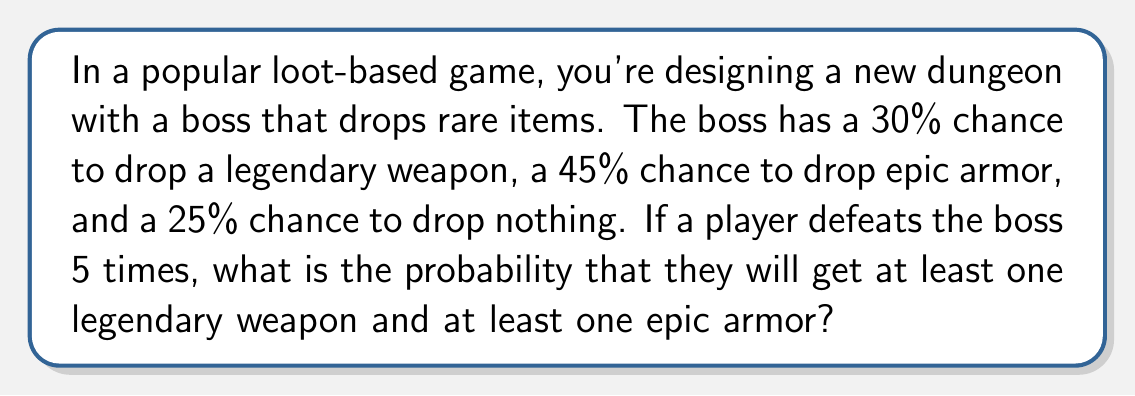Teach me how to tackle this problem. Let's approach this step-by-step:

1) First, we need to calculate the probability of not getting a legendary weapon in a single attempt:
   $P(\text{no legendary}) = 1 - 0.30 = 0.70$

2) The probability of not getting a legendary weapon in 5 attempts is:
   $P(\text{no legendary in 5 attempts}) = 0.70^5 = 0.16807$

3) Therefore, the probability of getting at least one legendary weapon in 5 attempts is:
   $P(\text{at least one legendary}) = 1 - 0.16807 = 0.83193$

4) Similarly for epic armor:
   $P(\text{no epic}) = 1 - 0.45 = 0.55$
   $P(\text{no epic in 5 attempts}) = 0.55^5 = 0.0503284375$
   $P(\text{at least one epic}) = 1 - 0.0503284375 = 0.9496715625$

5) Now, we need the probability of both events occurring. Since these events are independent, we multiply their probabilities:

   $$P(\text{at least one legendary AND at least one epic}) = 0.83193 \times 0.9496715625 = 0.7900372$$

6) Converting to a percentage:
   $0.7900372 \times 100\% = 79.00372\%$
Answer: The probability of getting at least one legendary weapon and at least one epic armor in 5 boss defeats is approximately $79.00\%$. 